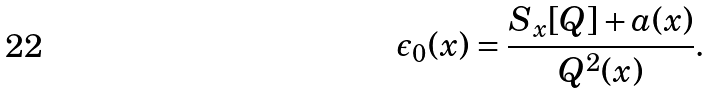<formula> <loc_0><loc_0><loc_500><loc_500>\epsilon _ { 0 } ( x ) = \frac { S _ { x } [ Q ] + a ( x ) } { Q ^ { 2 } ( x ) } .</formula> 